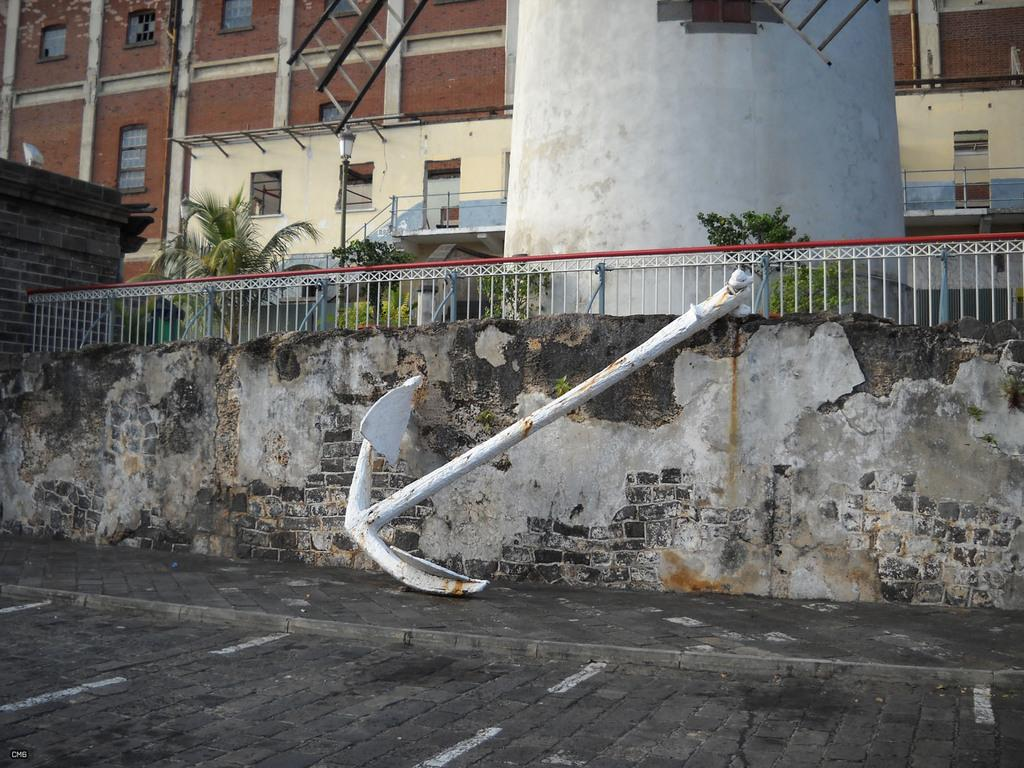What type of structure is visible in the image? There is a building in the image. What feature can be seen on the building? The building has windows. What type of natural elements are present in the image? There are plants and trees in the image. What type of renewable energy source is visible in the image? There is a wind turbine in the image. What type of architectural feature is present in the image? There is a railing in the image. What additional object is present in the image? There is an anchor in the image. Can you describe another architectural feature in the image? There is another railing in the image. What type of light can be seen emanating from the stem of the plant in the image? There is no light emanating from the stem of the plant in the image, as the facts provided do not mention any light source or bioluminescent plants. 